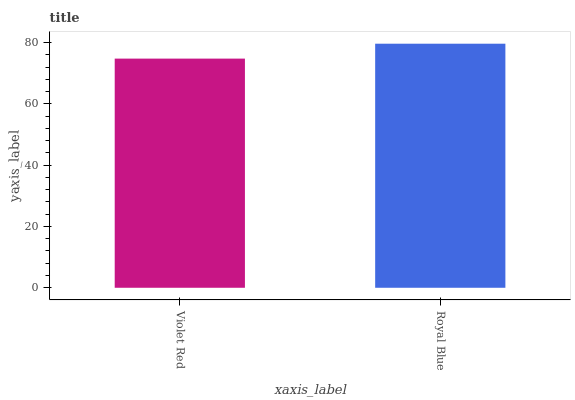Is Violet Red the minimum?
Answer yes or no. Yes. Is Royal Blue the maximum?
Answer yes or no. Yes. Is Royal Blue the minimum?
Answer yes or no. No. Is Royal Blue greater than Violet Red?
Answer yes or no. Yes. Is Violet Red less than Royal Blue?
Answer yes or no. Yes. Is Violet Red greater than Royal Blue?
Answer yes or no. No. Is Royal Blue less than Violet Red?
Answer yes or no. No. Is Royal Blue the high median?
Answer yes or no. Yes. Is Violet Red the low median?
Answer yes or no. Yes. Is Violet Red the high median?
Answer yes or no. No. Is Royal Blue the low median?
Answer yes or no. No. 